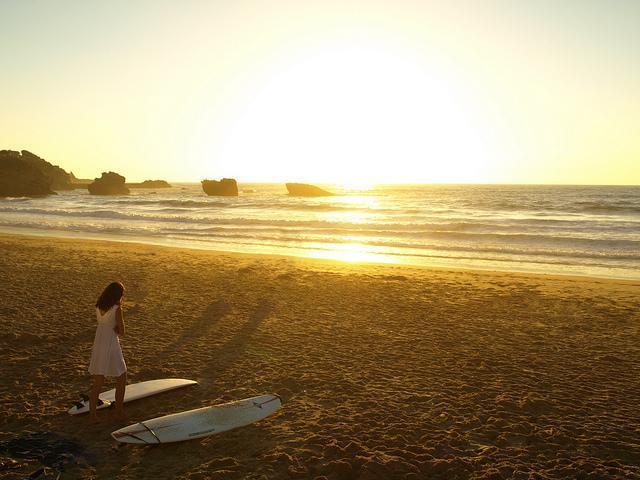How many people are there?
Give a very brief answer. 1. How many lights on the train are turned on?
Give a very brief answer. 0. 